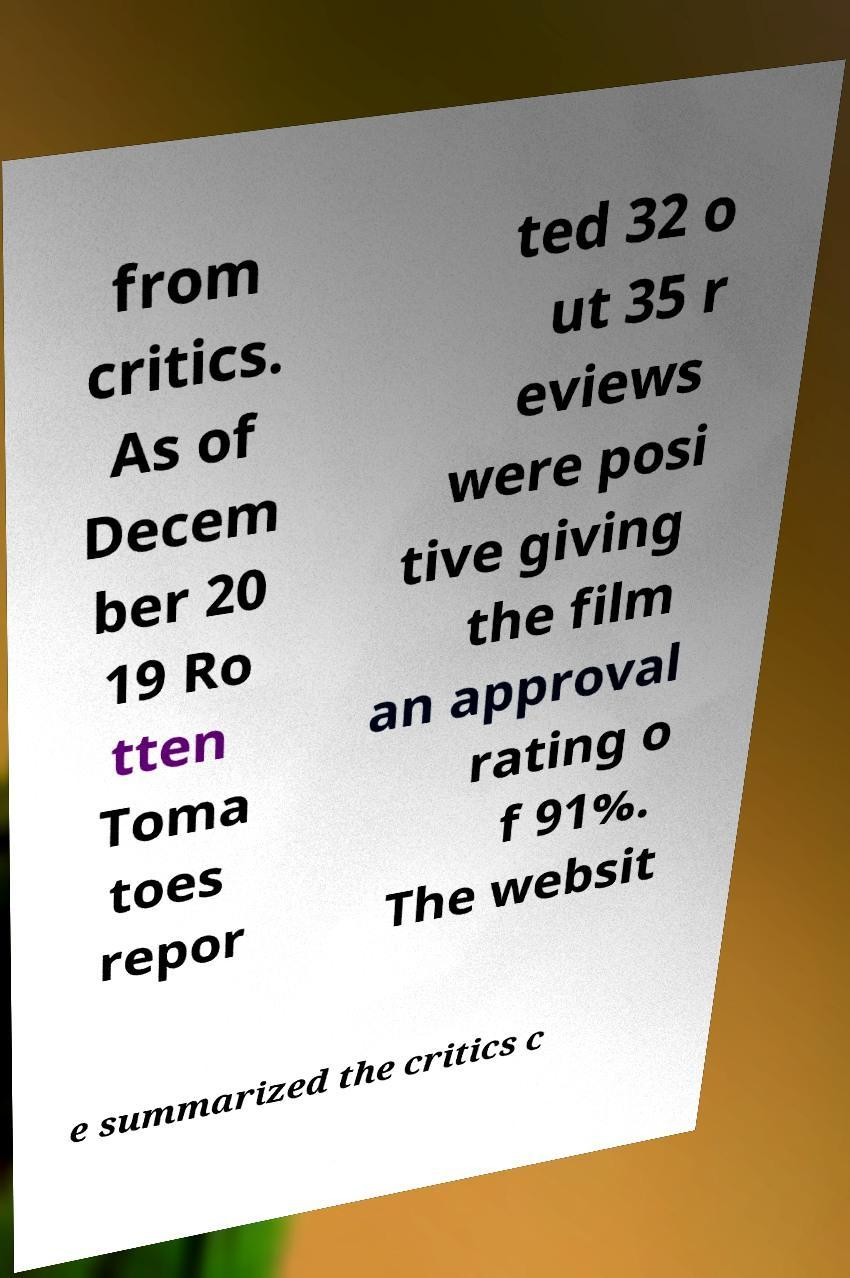Can you accurately transcribe the text from the provided image for me? from critics. As of Decem ber 20 19 Ro tten Toma toes repor ted 32 o ut 35 r eviews were posi tive giving the film an approval rating o f 91%. The websit e summarized the critics c 